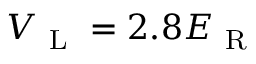<formula> <loc_0><loc_0><loc_500><loc_500>V _ { L } = 2 . 8 E _ { R }</formula> 